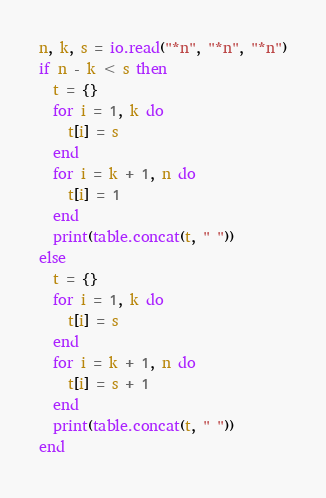Convert code to text. <code><loc_0><loc_0><loc_500><loc_500><_Lua_>n, k, s = io.read("*n", "*n", "*n")
if n - k < s then
  t = {}
  for i = 1, k do
    t[i] = s
  end
  for i = k + 1, n do
    t[i] = 1
  end
  print(table.concat(t, " "))
else
  t = {}
  for i = 1, k do
    t[i] = s
  end
  for i = k + 1, n do
    t[i] = s + 1
  end
  print(table.concat(t, " "))
end
</code> 